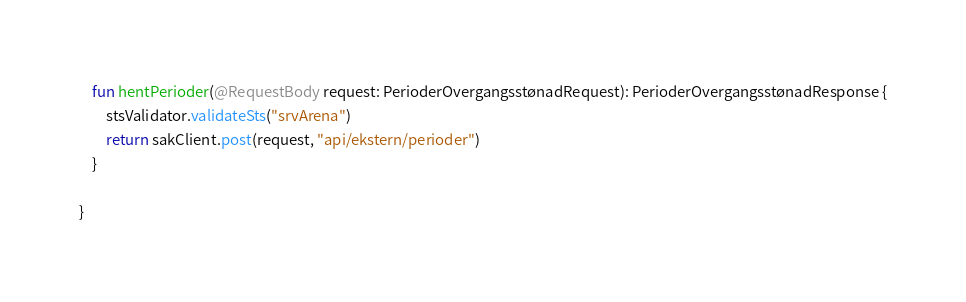<code> <loc_0><loc_0><loc_500><loc_500><_Kotlin_>    fun hentPerioder(@RequestBody request: PerioderOvergangsstønadRequest): PerioderOvergangsstønadResponse {
        stsValidator.validateSts("srvArena")
        return sakClient.post(request, "api/ekstern/perioder")
    }

}</code> 